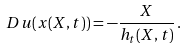Convert formula to latex. <formula><loc_0><loc_0><loc_500><loc_500>D u ( x ( X , t ) ) = - \frac { X } { h _ { t } ( X , t ) } \, .</formula> 